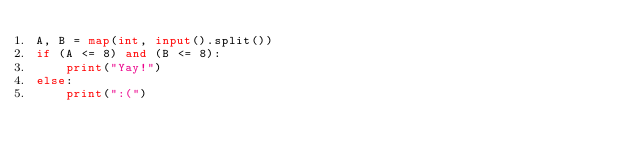Convert code to text. <code><loc_0><loc_0><loc_500><loc_500><_Python_>A, B = map(int, input().split())
if (A <= 8) and (B <= 8):
    print("Yay!")
else:
    print(":(")
</code> 